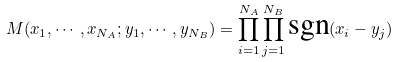<formula> <loc_0><loc_0><loc_500><loc_500>M ( x _ { 1 } , \cdots , x _ { N _ { A } } ; y _ { 1 } , \cdots , y _ { N _ { B } } ) = \prod _ { i = 1 } ^ { N _ { A } } \prod _ { j = 1 } ^ { N _ { B } } \text {sgn} ( x _ { i } - y _ { j } )</formula> 